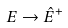<formula> <loc_0><loc_0><loc_500><loc_500>E \rightarrow \hat { E } ^ { + }</formula> 